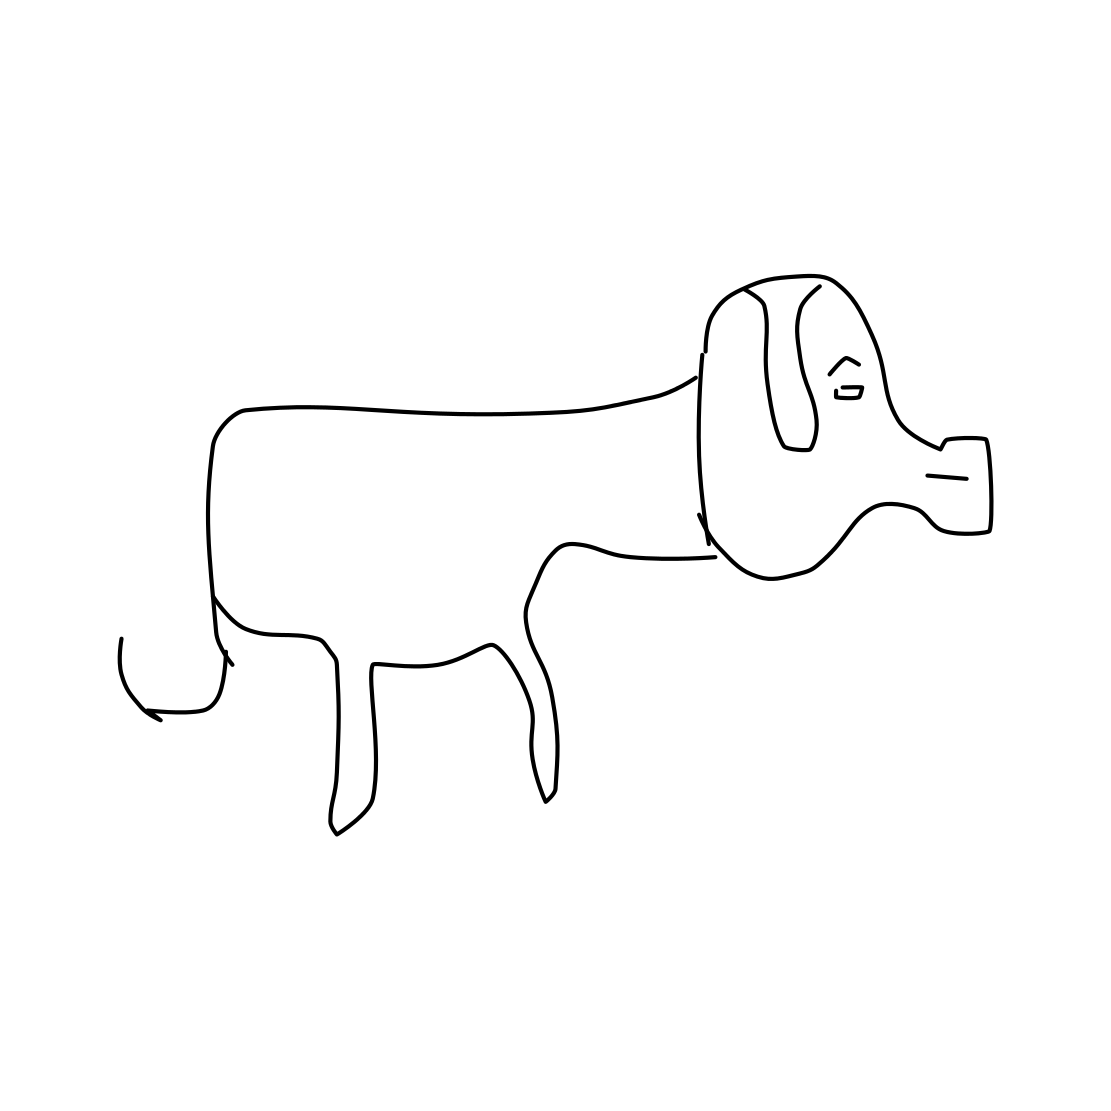Is this a dog in the image? Yes 